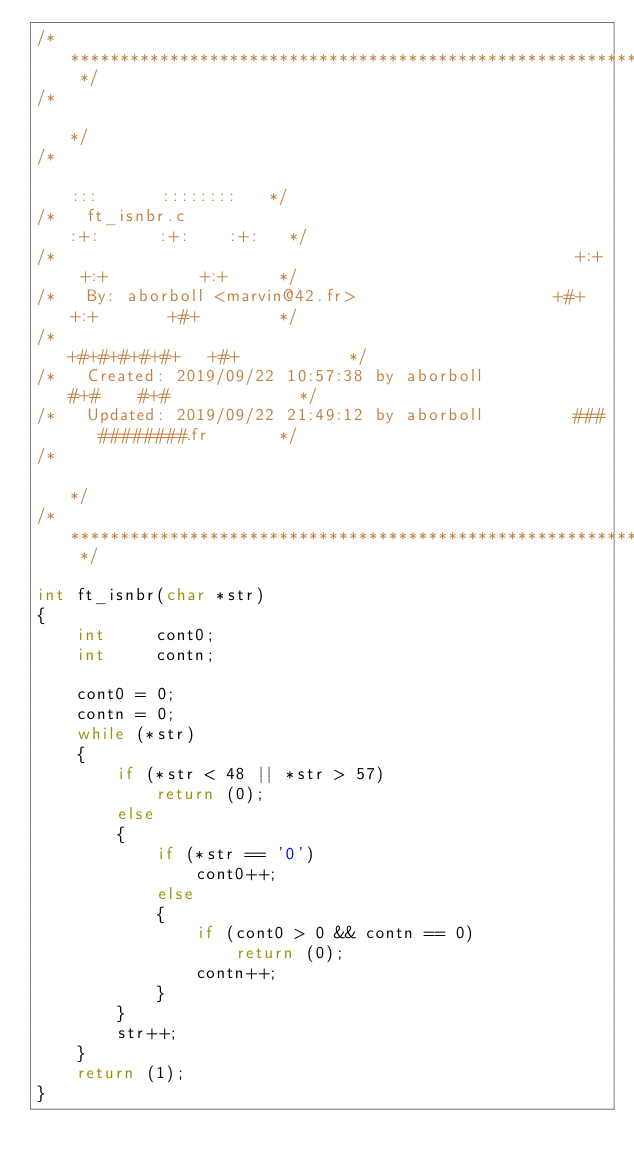<code> <loc_0><loc_0><loc_500><loc_500><_C_>/* ************************************************************************** */
/*                                                                            */
/*                                                        :::      ::::::::   */
/*   ft_isnbr.c                                         :+:      :+:    :+:   */
/*                                                    +:+ +:+         +:+     */
/*   By: aborboll <marvin@42.fr>                    +#+  +:+       +#+        */
/*                                                +#+#+#+#+#+   +#+           */
/*   Created: 2019/09/22 10:57:38 by aborboll          #+#    #+#             */
/*   Updated: 2019/09/22 21:49:12 by aborboll         ###   ########.fr       */
/*                                                                            */
/* ************************************************************************** */

int	ft_isnbr(char *str)
{
	int		cont0;
	int		contn;

	cont0 = 0;
	contn = 0;
	while (*str)
	{
		if (*str < 48 || *str > 57)
			return (0);
		else
		{
			if (*str == '0')
				cont0++;
			else
			{
				if (cont0 > 0 && contn == 0)
					return (0);
				contn++;
			}
		}
		str++;
	}
	return (1);
}
</code> 